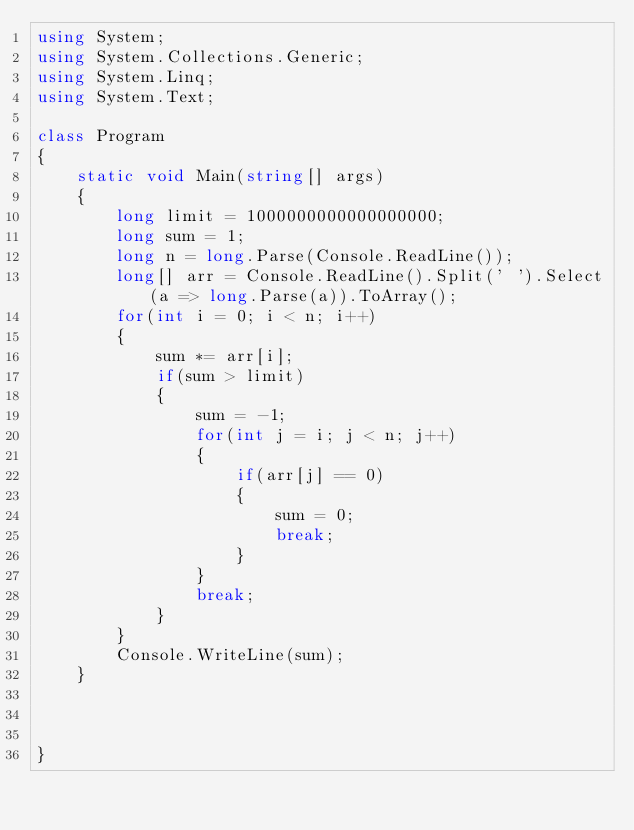Convert code to text. <code><loc_0><loc_0><loc_500><loc_500><_C#_>using System;
using System.Collections.Generic;
using System.Linq;
using System.Text;

class Program
{
    static void Main(string[] args)
    {
        long limit = 1000000000000000000;
        long sum = 1;
        long n = long.Parse(Console.ReadLine());
        long[] arr = Console.ReadLine().Split(' ').Select(a => long.Parse(a)).ToArray();
        for(int i = 0; i < n; i++)
        {
            sum *= arr[i];
            if(sum > limit)
            {
                sum = -1;
                for(int j = i; j < n; j++)
                {
                    if(arr[j] == 0)
                    {
                        sum = 0;
                        break;
                    }
                }
                break;
            }
        }
        Console.WriteLine(sum);
    }

   

}


</code> 